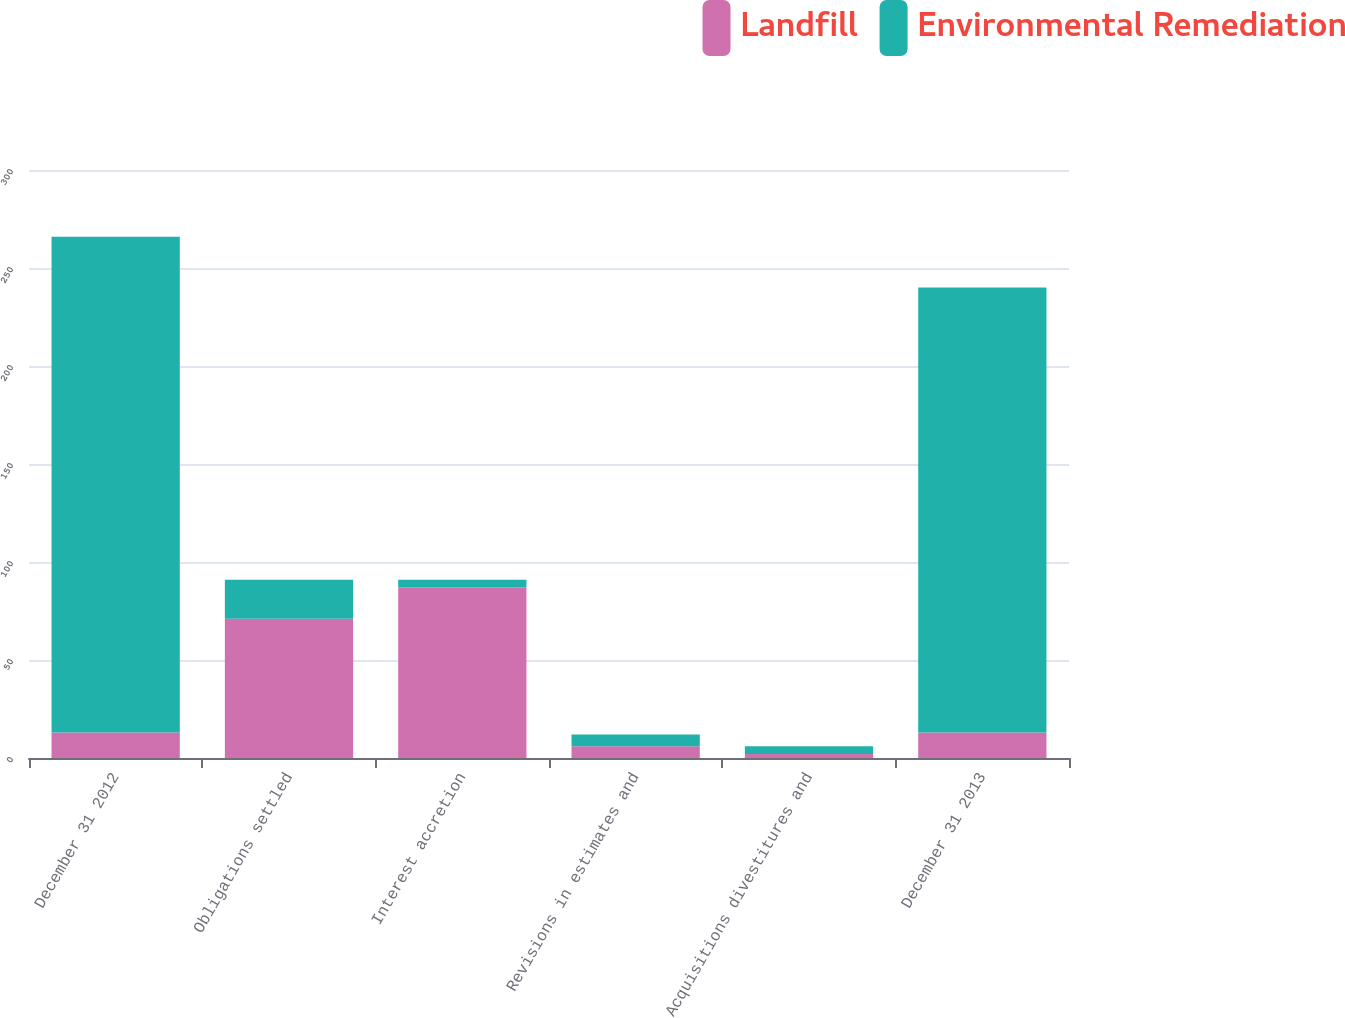Convert chart to OTSL. <chart><loc_0><loc_0><loc_500><loc_500><stacked_bar_chart><ecel><fcel>December 31 2012<fcel>Obligations settled<fcel>Interest accretion<fcel>Revisions in estimates and<fcel>Acquisitions divestitures and<fcel>December 31 2013<nl><fcel>Landfill<fcel>13<fcel>71<fcel>87<fcel>6<fcel>2<fcel>13<nl><fcel>Environmental Remediation<fcel>253<fcel>20<fcel>4<fcel>6<fcel>4<fcel>227<nl></chart> 